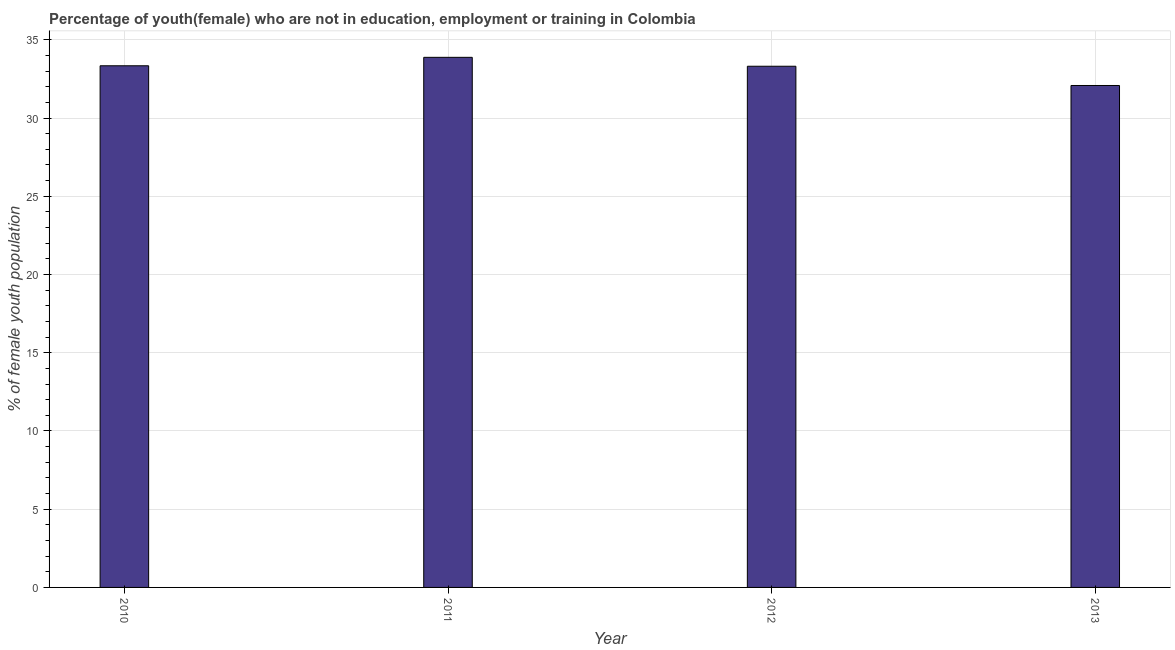What is the title of the graph?
Offer a very short reply. Percentage of youth(female) who are not in education, employment or training in Colombia. What is the label or title of the X-axis?
Keep it short and to the point. Year. What is the label or title of the Y-axis?
Your response must be concise. % of female youth population. What is the unemployed female youth population in 2013?
Offer a very short reply. 32.08. Across all years, what is the maximum unemployed female youth population?
Provide a succinct answer. 33.88. Across all years, what is the minimum unemployed female youth population?
Make the answer very short. 32.08. In which year was the unemployed female youth population maximum?
Keep it short and to the point. 2011. In which year was the unemployed female youth population minimum?
Provide a short and direct response. 2013. What is the sum of the unemployed female youth population?
Make the answer very short. 132.61. What is the difference between the unemployed female youth population in 2012 and 2013?
Give a very brief answer. 1.23. What is the average unemployed female youth population per year?
Ensure brevity in your answer.  33.15. What is the median unemployed female youth population?
Provide a succinct answer. 33.33. In how many years, is the unemployed female youth population greater than 17 %?
Offer a terse response. 4. What is the ratio of the unemployed female youth population in 2010 to that in 2012?
Make the answer very short. 1. Is the difference between the unemployed female youth population in 2011 and 2013 greater than the difference between any two years?
Your answer should be very brief. Yes. What is the difference between the highest and the second highest unemployed female youth population?
Offer a very short reply. 0.54. Is the sum of the unemployed female youth population in 2010 and 2011 greater than the maximum unemployed female youth population across all years?
Your response must be concise. Yes. In how many years, is the unemployed female youth population greater than the average unemployed female youth population taken over all years?
Provide a short and direct response. 3. How many bars are there?
Offer a very short reply. 4. Are all the bars in the graph horizontal?
Your answer should be compact. No. How many years are there in the graph?
Your response must be concise. 4. What is the difference between two consecutive major ticks on the Y-axis?
Offer a terse response. 5. What is the % of female youth population in 2010?
Offer a very short reply. 33.34. What is the % of female youth population in 2011?
Offer a very short reply. 33.88. What is the % of female youth population of 2012?
Your response must be concise. 33.31. What is the % of female youth population in 2013?
Offer a terse response. 32.08. What is the difference between the % of female youth population in 2010 and 2011?
Ensure brevity in your answer.  -0.54. What is the difference between the % of female youth population in 2010 and 2013?
Make the answer very short. 1.26. What is the difference between the % of female youth population in 2011 and 2012?
Make the answer very short. 0.57. What is the difference between the % of female youth population in 2011 and 2013?
Give a very brief answer. 1.8. What is the difference between the % of female youth population in 2012 and 2013?
Offer a very short reply. 1.23. What is the ratio of the % of female youth population in 2010 to that in 2013?
Provide a short and direct response. 1.04. What is the ratio of the % of female youth population in 2011 to that in 2012?
Keep it short and to the point. 1.02. What is the ratio of the % of female youth population in 2011 to that in 2013?
Offer a terse response. 1.06. What is the ratio of the % of female youth population in 2012 to that in 2013?
Offer a very short reply. 1.04. 